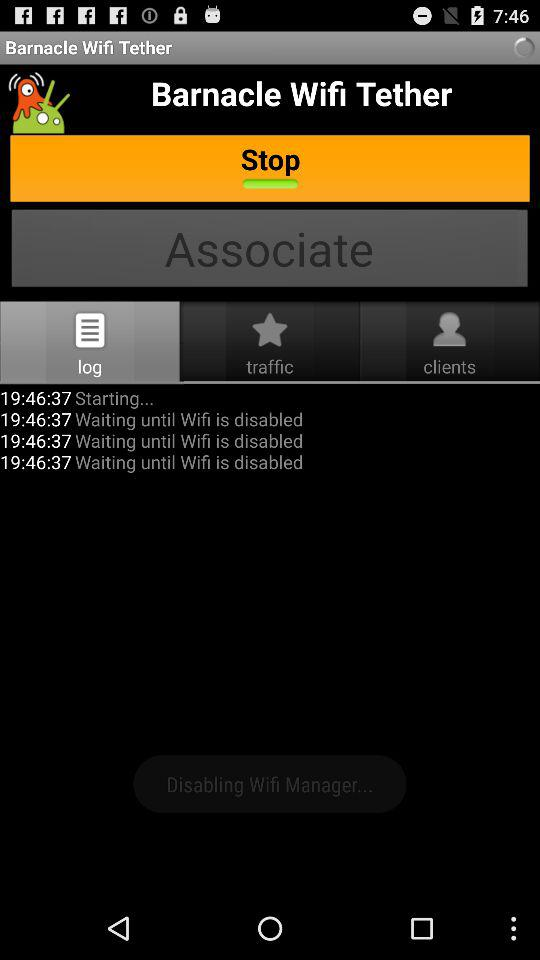What is the name of the application? The name of the application is "Barnacle Wifi Tether". 